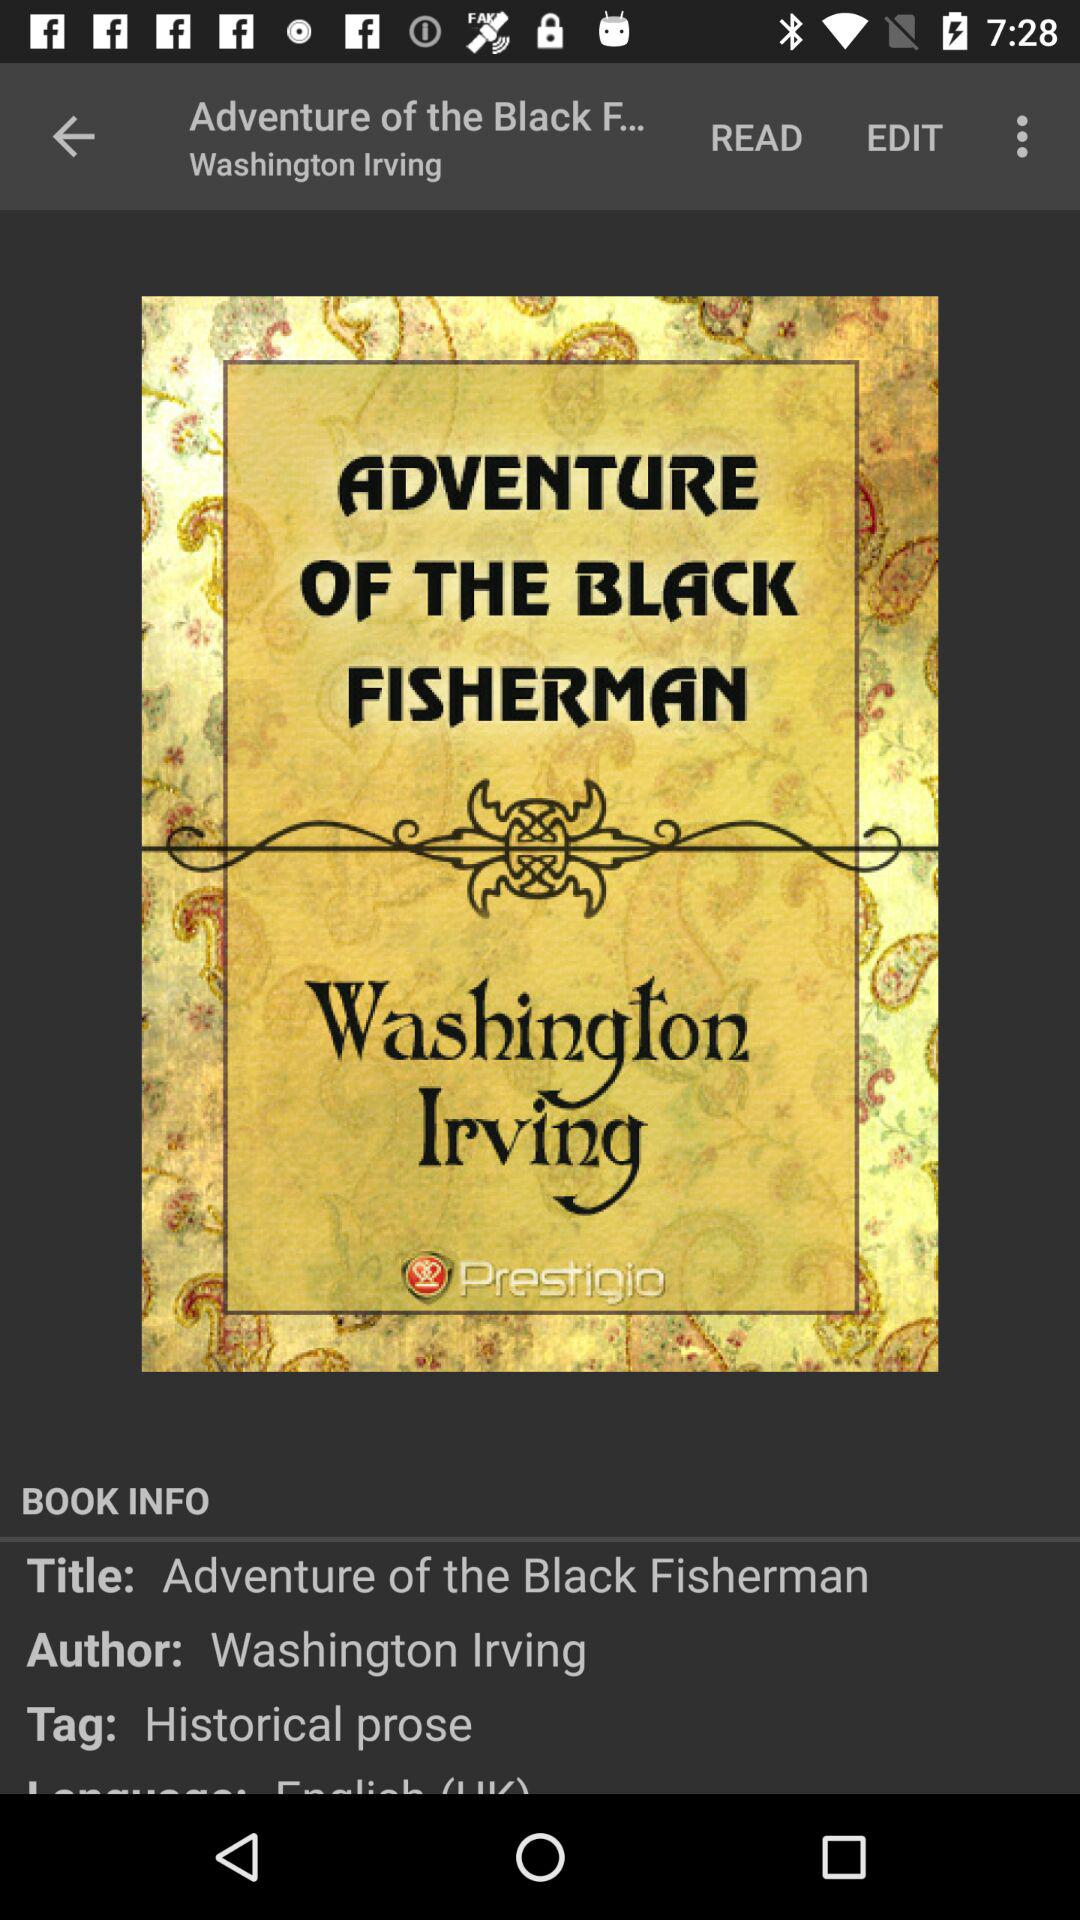What's the tag? The tag is "Historical prose". 